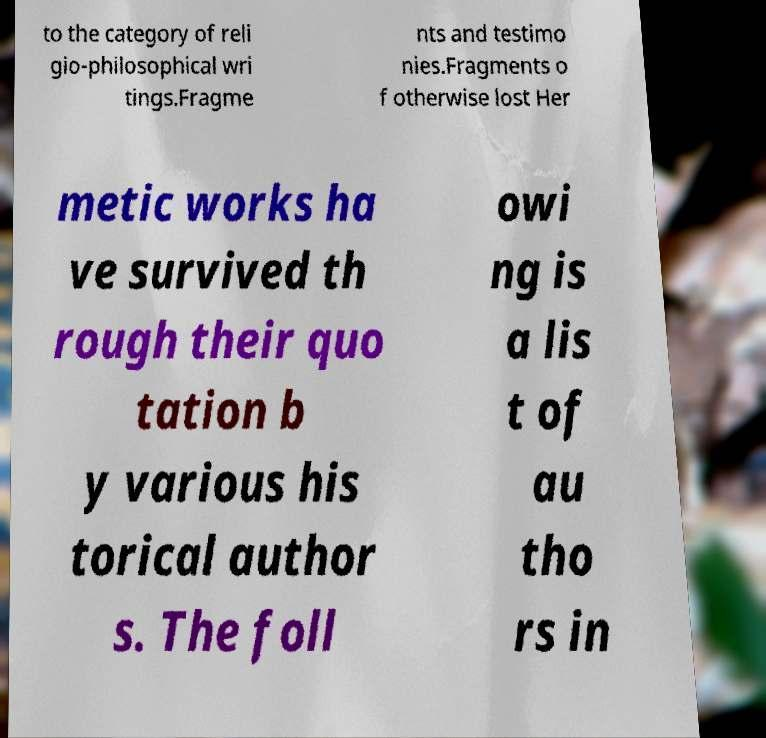I need the written content from this picture converted into text. Can you do that? to the category of reli gio-philosophical wri tings.Fragme nts and testimo nies.Fragments o f otherwise lost Her metic works ha ve survived th rough their quo tation b y various his torical author s. The foll owi ng is a lis t of au tho rs in 